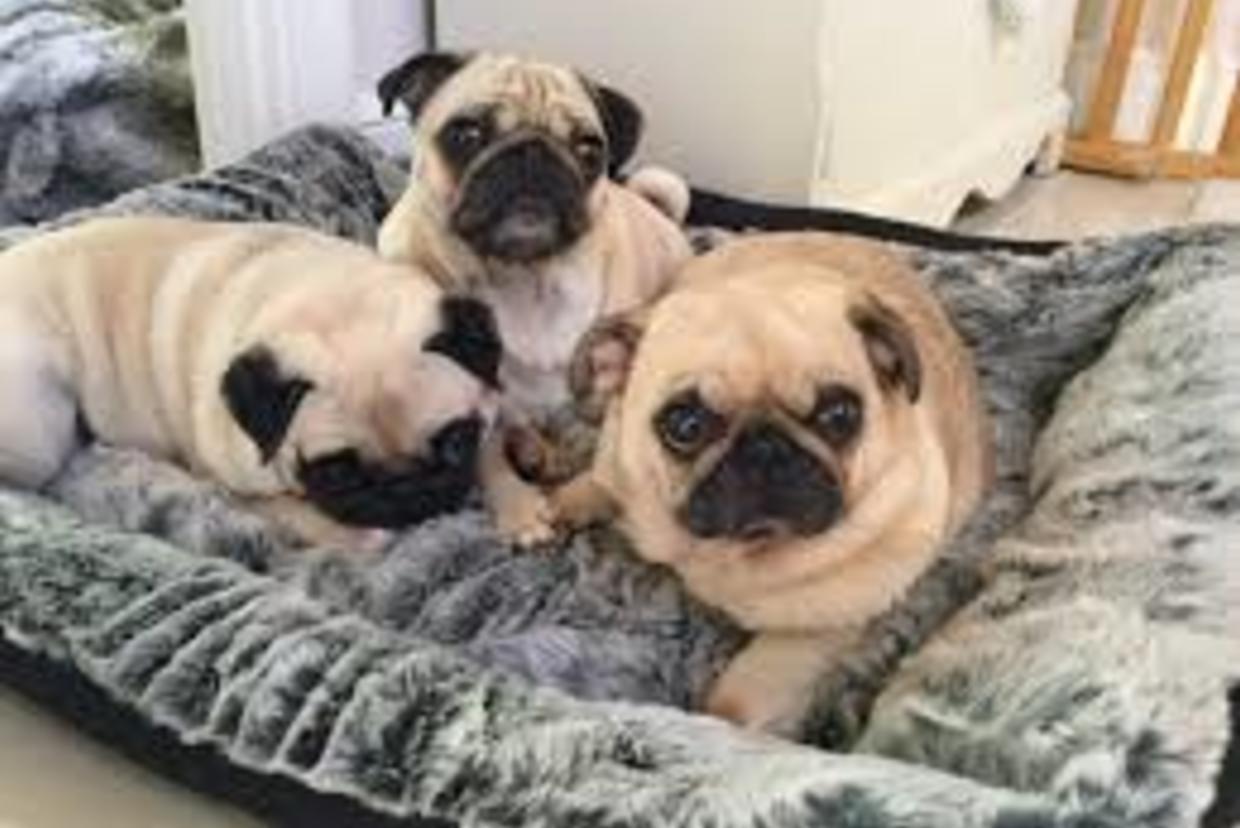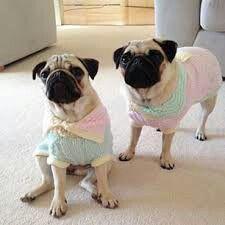The first image is the image on the left, the second image is the image on the right. Analyze the images presented: Is the assertion "A dog is wearing something on its head." valid? Answer yes or no. No. The first image is the image on the left, the second image is the image on the right. Given the left and right images, does the statement "At least one image shows a human behind the dog hugging it." hold true? Answer yes or no. No. 